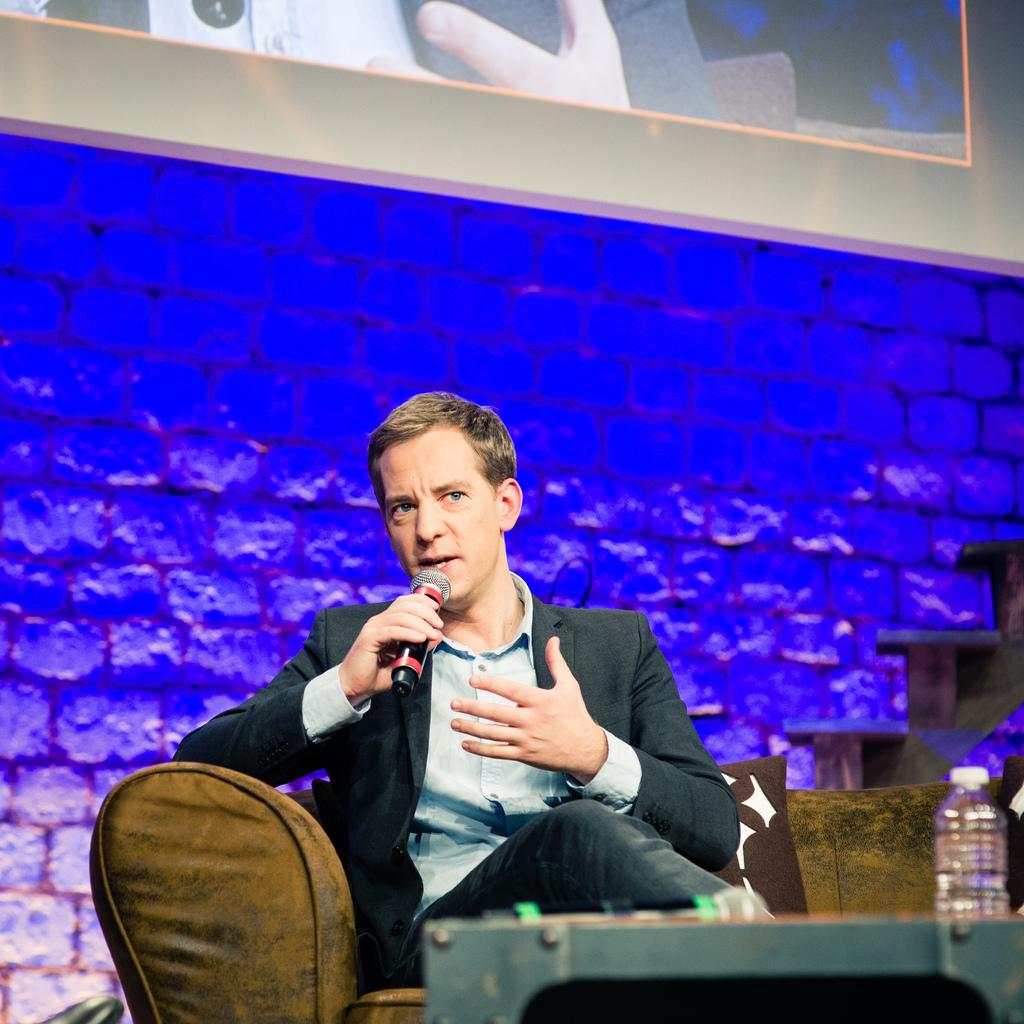Who is present in the image? There is a man in the image. What is the man doing in the image? The man is sitting on a sofa and holding a mic. What can be seen on the sofa with the man? There is a pillow in the image. What other objects are visible in the image? There is a bottle and a table in the image. What is on the wall in the background? There is a screen on the wall in the background. What type of oil can be seen dripping from the screen in the image? There is no oil or dripping substance present in the image. The screen on the wall is not depicted as having any liquid or substance on it. 